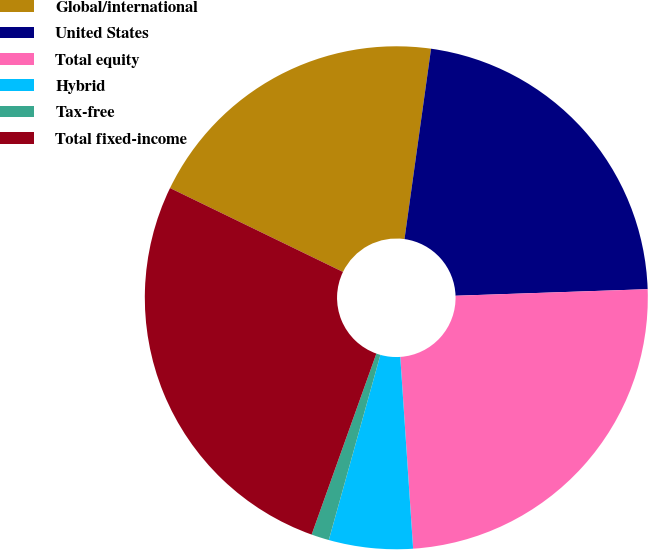Convert chart to OTSL. <chart><loc_0><loc_0><loc_500><loc_500><pie_chart><fcel>Global/international<fcel>United States<fcel>Total equity<fcel>Hybrid<fcel>Tax-free<fcel>Total fixed-income<nl><fcel>20.02%<fcel>22.25%<fcel>24.48%<fcel>5.39%<fcel>1.14%<fcel>26.72%<nl></chart> 